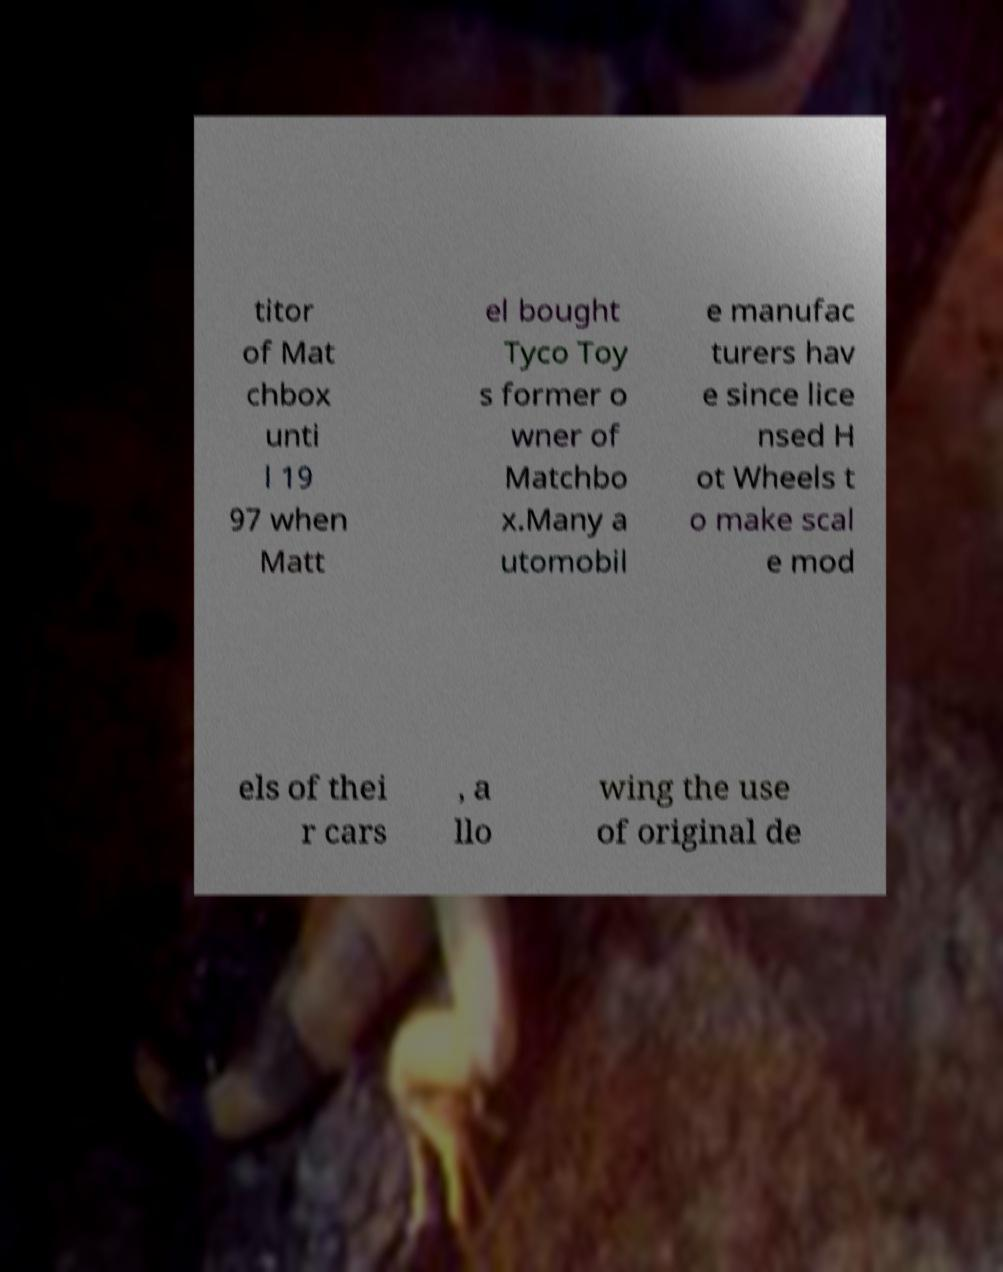Can you read and provide the text displayed in the image?This photo seems to have some interesting text. Can you extract and type it out for me? titor of Mat chbox unti l 19 97 when Matt el bought Tyco Toy s former o wner of Matchbo x.Many a utomobil e manufac turers hav e since lice nsed H ot Wheels t o make scal e mod els of thei r cars , a llo wing the use of original de 